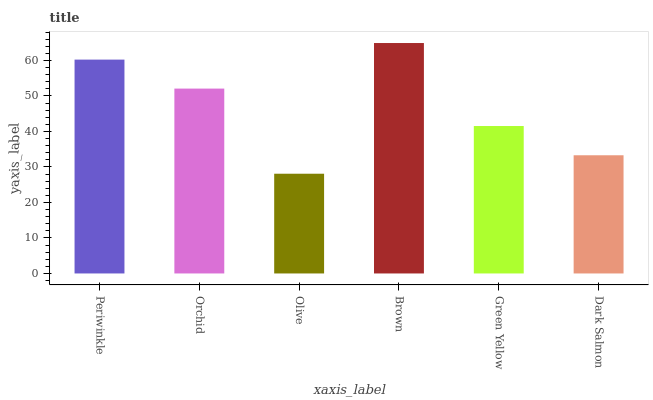Is Olive the minimum?
Answer yes or no. Yes. Is Brown the maximum?
Answer yes or no. Yes. Is Orchid the minimum?
Answer yes or no. No. Is Orchid the maximum?
Answer yes or no. No. Is Periwinkle greater than Orchid?
Answer yes or no. Yes. Is Orchid less than Periwinkle?
Answer yes or no. Yes. Is Orchid greater than Periwinkle?
Answer yes or no. No. Is Periwinkle less than Orchid?
Answer yes or no. No. Is Orchid the high median?
Answer yes or no. Yes. Is Green Yellow the low median?
Answer yes or no. Yes. Is Olive the high median?
Answer yes or no. No. Is Orchid the low median?
Answer yes or no. No. 